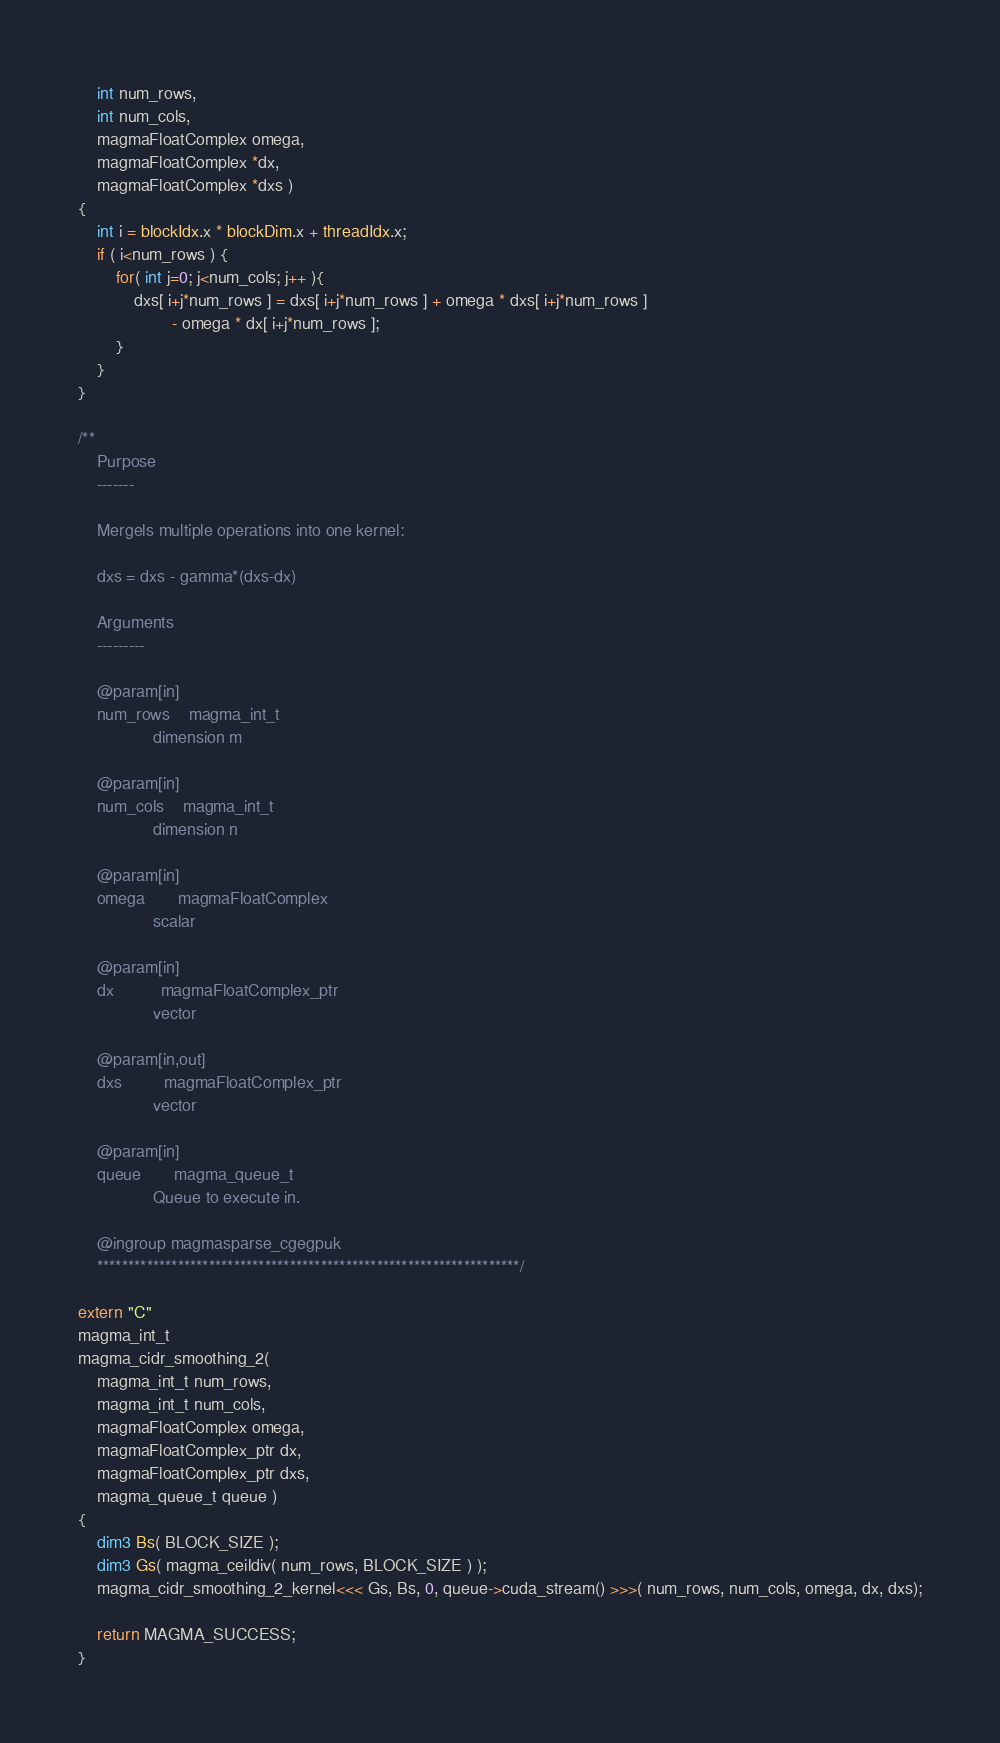<code> <loc_0><loc_0><loc_500><loc_500><_Cuda_>    int num_rows,
    int num_cols,
    magmaFloatComplex omega,
    magmaFloatComplex *dx,
    magmaFloatComplex *dxs )
{
    int i = blockIdx.x * blockDim.x + threadIdx.x;
    if ( i<num_rows ) {
        for( int j=0; j<num_cols; j++ ){
            dxs[ i+j*num_rows ] = dxs[ i+j*num_rows ] + omega * dxs[ i+j*num_rows ]
                    - omega * dx[ i+j*num_rows ];
        }
    }
}

/**
    Purpose
    -------

    Mergels multiple operations into one kernel:

    dxs = dxs - gamma*(dxs-dx)

    Arguments
    ---------

    @param[in]
    num_rows    magma_int_t
                dimension m
                
    @param[in]
    num_cols    magma_int_t
                dimension n
                
    @param[in]
    omega       magmaFloatComplex
                scalar
                
    @param[in]
    dx          magmaFloatComplex_ptr 
                vector

    @param[in,out]
    dxs         magmaFloatComplex_ptr 
                vector

    @param[in]
    queue       magma_queue_t
                Queue to execute in.

    @ingroup magmasparse_cgegpuk
    ********************************************************************/

extern "C" 
magma_int_t
magma_cidr_smoothing_2(  
    magma_int_t num_rows, 
    magma_int_t num_cols, 
    magmaFloatComplex omega,
    magmaFloatComplex_ptr dx,
    magmaFloatComplex_ptr dxs, 
    magma_queue_t queue )
{
    dim3 Bs( BLOCK_SIZE );
    dim3 Gs( magma_ceildiv( num_rows, BLOCK_SIZE ) );
    magma_cidr_smoothing_2_kernel<<< Gs, Bs, 0, queue->cuda_stream() >>>( num_rows, num_cols, omega, dx, dxs);

    return MAGMA_SUCCESS;
}
</code> 